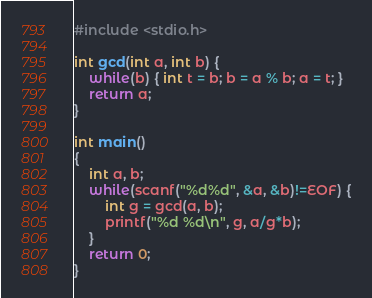Convert code to text. <code><loc_0><loc_0><loc_500><loc_500><_C++_>#include <stdio.h>

int gcd(int a, int b) {
	while(b) { int t = b; b = a % b; a = t; }
	return a;
}

int main()
{
	int a, b;
	while(scanf("%d%d", &a, &b)!=EOF) {
		int g = gcd(a, b);
		printf("%d %d\n", g, a/g*b);
	}
	return 0;
}</code> 